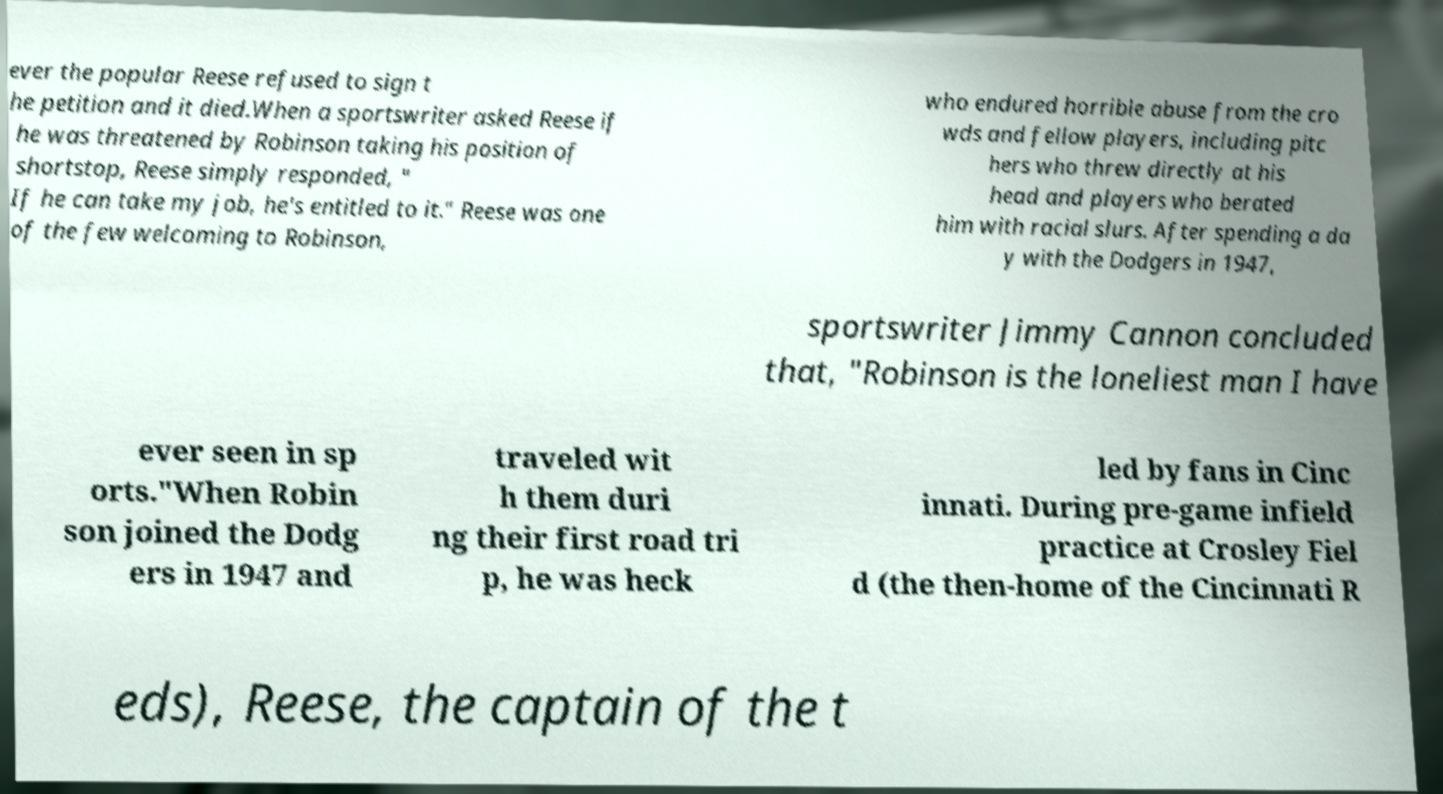Could you assist in decoding the text presented in this image and type it out clearly? ever the popular Reese refused to sign t he petition and it died.When a sportswriter asked Reese if he was threatened by Robinson taking his position of shortstop, Reese simply responded, " If he can take my job, he's entitled to it." Reese was one of the few welcoming to Robinson, who endured horrible abuse from the cro wds and fellow players, including pitc hers who threw directly at his head and players who berated him with racial slurs. After spending a da y with the Dodgers in 1947, sportswriter Jimmy Cannon concluded that, "Robinson is the loneliest man I have ever seen in sp orts."When Robin son joined the Dodg ers in 1947 and traveled wit h them duri ng their first road tri p, he was heck led by fans in Cinc innati. During pre-game infield practice at Crosley Fiel d (the then-home of the Cincinnati R eds), Reese, the captain of the t 